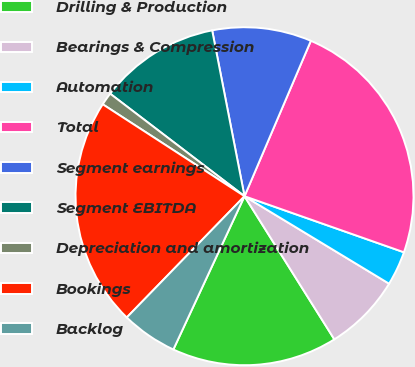<chart> <loc_0><loc_0><loc_500><loc_500><pie_chart><fcel>Drilling & Production<fcel>Bearings & Compression<fcel>Automation<fcel>Total<fcel>Segment earnings<fcel>Segment EBITDA<fcel>Depreciation and amortization<fcel>Bookings<fcel>Backlog<nl><fcel>15.84%<fcel>7.42%<fcel>3.28%<fcel>23.96%<fcel>9.49%<fcel>11.56%<fcel>1.22%<fcel>21.89%<fcel>5.35%<nl></chart> 